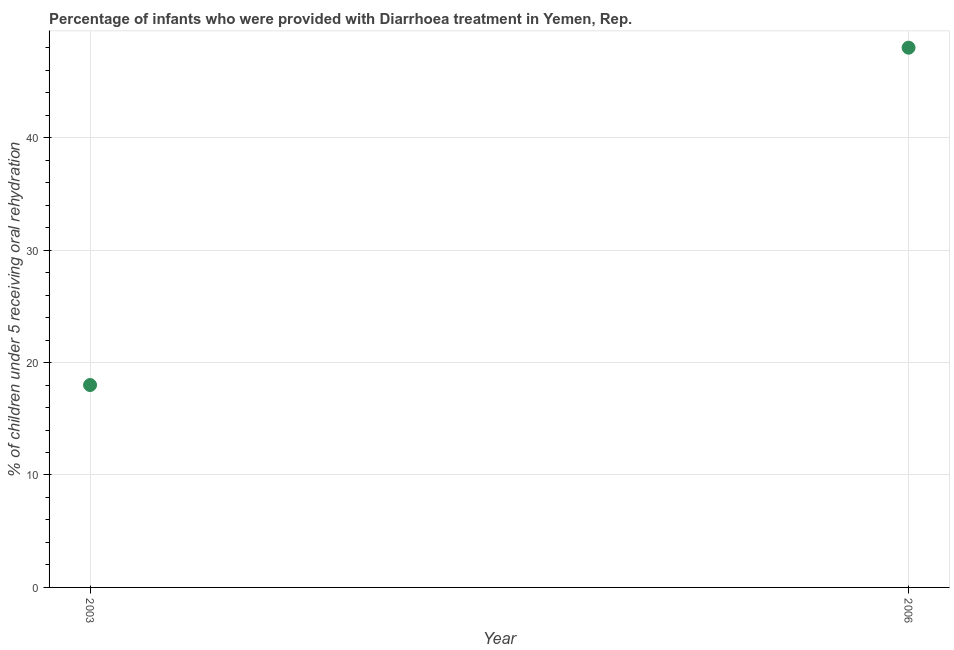What is the percentage of children who were provided with treatment diarrhoea in 2006?
Give a very brief answer. 48. Across all years, what is the maximum percentage of children who were provided with treatment diarrhoea?
Your answer should be very brief. 48. Across all years, what is the minimum percentage of children who were provided with treatment diarrhoea?
Give a very brief answer. 18. In which year was the percentage of children who were provided with treatment diarrhoea maximum?
Provide a short and direct response. 2006. What is the sum of the percentage of children who were provided with treatment diarrhoea?
Offer a very short reply. 66. What is the difference between the percentage of children who were provided with treatment diarrhoea in 2003 and 2006?
Your response must be concise. -30. In how many years, is the percentage of children who were provided with treatment diarrhoea greater than 4 %?
Offer a terse response. 2. Do a majority of the years between 2003 and 2006 (inclusive) have percentage of children who were provided with treatment diarrhoea greater than 16 %?
Your response must be concise. Yes. What is the ratio of the percentage of children who were provided with treatment diarrhoea in 2003 to that in 2006?
Keep it short and to the point. 0.38. Is the percentage of children who were provided with treatment diarrhoea in 2003 less than that in 2006?
Offer a very short reply. Yes. How many dotlines are there?
Offer a terse response. 1. Does the graph contain any zero values?
Offer a terse response. No. What is the title of the graph?
Provide a short and direct response. Percentage of infants who were provided with Diarrhoea treatment in Yemen, Rep. What is the label or title of the X-axis?
Offer a very short reply. Year. What is the label or title of the Y-axis?
Your response must be concise. % of children under 5 receiving oral rehydration. What is the % of children under 5 receiving oral rehydration in 2006?
Provide a short and direct response. 48. 